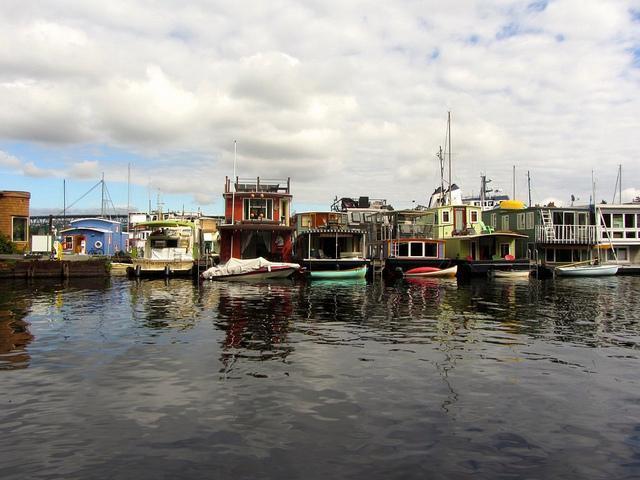How many boats can be seen?
Give a very brief answer. 5. 